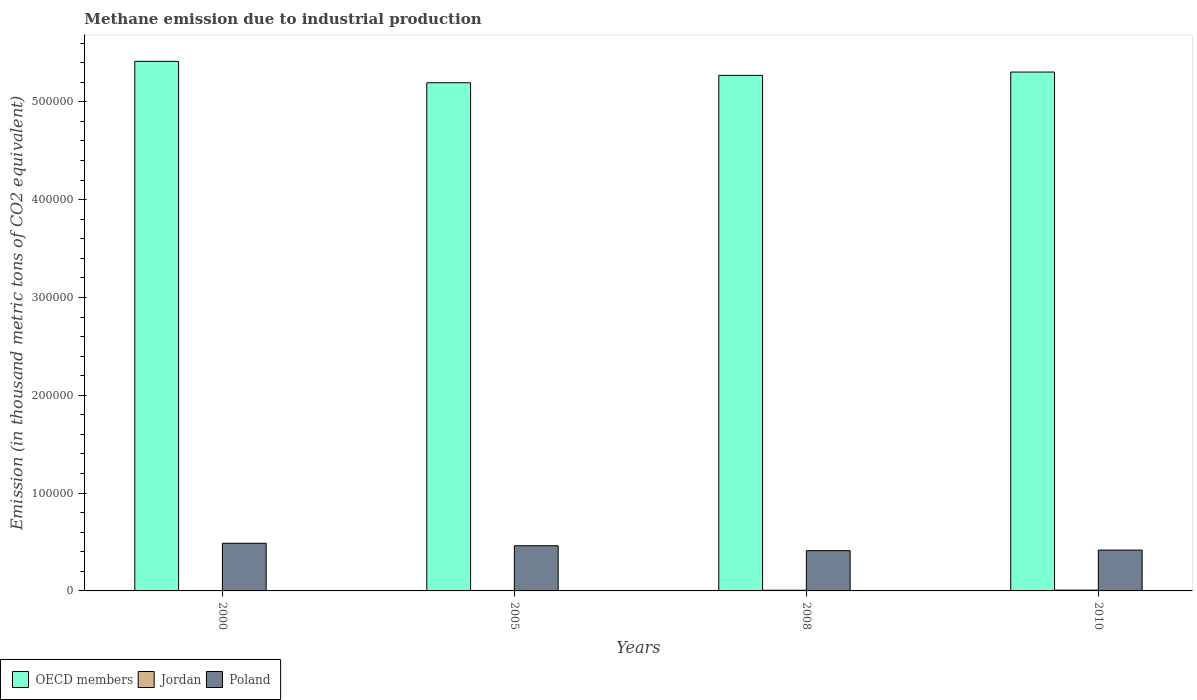How many different coloured bars are there?
Ensure brevity in your answer.  3. How many groups of bars are there?
Offer a terse response. 4. What is the label of the 4th group of bars from the left?
Offer a terse response. 2010. What is the amount of methane emitted in Jordan in 2008?
Provide a short and direct response. 681.7. Across all years, what is the maximum amount of methane emitted in Poland?
Provide a short and direct response. 4.87e+04. Across all years, what is the minimum amount of methane emitted in Poland?
Your answer should be compact. 4.12e+04. What is the total amount of methane emitted in Poland in the graph?
Your response must be concise. 1.78e+05. What is the difference between the amount of methane emitted in Jordan in 2008 and that in 2010?
Ensure brevity in your answer.  -123.7. What is the difference between the amount of methane emitted in Poland in 2008 and the amount of methane emitted in Jordan in 2000?
Your answer should be very brief. 4.09e+04. What is the average amount of methane emitted in OECD members per year?
Ensure brevity in your answer.  5.30e+05. In the year 2005, what is the difference between the amount of methane emitted in Poland and amount of methane emitted in OECD members?
Your response must be concise. -4.73e+05. In how many years, is the amount of methane emitted in Poland greater than 20000 thousand metric tons?
Your answer should be compact. 4. What is the ratio of the amount of methane emitted in Jordan in 2000 to that in 2010?
Your response must be concise. 0.29. Is the amount of methane emitted in OECD members in 2000 less than that in 2010?
Make the answer very short. No. What is the difference between the highest and the second highest amount of methane emitted in Poland?
Keep it short and to the point. 2536.5. What is the difference between the highest and the lowest amount of methane emitted in Poland?
Your response must be concise. 7532.6. In how many years, is the amount of methane emitted in Poland greater than the average amount of methane emitted in Poland taken over all years?
Give a very brief answer. 2. What does the 2nd bar from the left in 2000 represents?
Ensure brevity in your answer.  Jordan. Is it the case that in every year, the sum of the amount of methane emitted in OECD members and amount of methane emitted in Poland is greater than the amount of methane emitted in Jordan?
Keep it short and to the point. Yes. How many bars are there?
Your response must be concise. 12. How many years are there in the graph?
Offer a terse response. 4. What is the difference between two consecutive major ticks on the Y-axis?
Keep it short and to the point. 1.00e+05. Are the values on the major ticks of Y-axis written in scientific E-notation?
Make the answer very short. No. Does the graph contain grids?
Make the answer very short. No. How many legend labels are there?
Provide a succinct answer. 3. What is the title of the graph?
Your answer should be very brief. Methane emission due to industrial production. What is the label or title of the Y-axis?
Keep it short and to the point. Emission (in thousand metric tons of CO2 equivalent). What is the Emission (in thousand metric tons of CO2 equivalent) in OECD members in 2000?
Make the answer very short. 5.41e+05. What is the Emission (in thousand metric tons of CO2 equivalent) of Jordan in 2000?
Ensure brevity in your answer.  231.4. What is the Emission (in thousand metric tons of CO2 equivalent) in Poland in 2000?
Give a very brief answer. 4.87e+04. What is the Emission (in thousand metric tons of CO2 equivalent) of OECD members in 2005?
Your response must be concise. 5.19e+05. What is the Emission (in thousand metric tons of CO2 equivalent) of Jordan in 2005?
Your answer should be compact. 486.3. What is the Emission (in thousand metric tons of CO2 equivalent) of Poland in 2005?
Provide a short and direct response. 4.62e+04. What is the Emission (in thousand metric tons of CO2 equivalent) of OECD members in 2008?
Ensure brevity in your answer.  5.27e+05. What is the Emission (in thousand metric tons of CO2 equivalent) in Jordan in 2008?
Your response must be concise. 681.7. What is the Emission (in thousand metric tons of CO2 equivalent) of Poland in 2008?
Keep it short and to the point. 4.12e+04. What is the Emission (in thousand metric tons of CO2 equivalent) of OECD members in 2010?
Offer a terse response. 5.30e+05. What is the Emission (in thousand metric tons of CO2 equivalent) in Jordan in 2010?
Keep it short and to the point. 805.4. What is the Emission (in thousand metric tons of CO2 equivalent) of Poland in 2010?
Your response must be concise. 4.17e+04. Across all years, what is the maximum Emission (in thousand metric tons of CO2 equivalent) in OECD members?
Make the answer very short. 5.41e+05. Across all years, what is the maximum Emission (in thousand metric tons of CO2 equivalent) in Jordan?
Offer a terse response. 805.4. Across all years, what is the maximum Emission (in thousand metric tons of CO2 equivalent) in Poland?
Give a very brief answer. 4.87e+04. Across all years, what is the minimum Emission (in thousand metric tons of CO2 equivalent) in OECD members?
Ensure brevity in your answer.  5.19e+05. Across all years, what is the minimum Emission (in thousand metric tons of CO2 equivalent) in Jordan?
Keep it short and to the point. 231.4. Across all years, what is the minimum Emission (in thousand metric tons of CO2 equivalent) in Poland?
Your answer should be compact. 4.12e+04. What is the total Emission (in thousand metric tons of CO2 equivalent) of OECD members in the graph?
Your response must be concise. 2.12e+06. What is the total Emission (in thousand metric tons of CO2 equivalent) of Jordan in the graph?
Make the answer very short. 2204.8. What is the total Emission (in thousand metric tons of CO2 equivalent) in Poland in the graph?
Your response must be concise. 1.78e+05. What is the difference between the Emission (in thousand metric tons of CO2 equivalent) in OECD members in 2000 and that in 2005?
Provide a short and direct response. 2.19e+04. What is the difference between the Emission (in thousand metric tons of CO2 equivalent) in Jordan in 2000 and that in 2005?
Ensure brevity in your answer.  -254.9. What is the difference between the Emission (in thousand metric tons of CO2 equivalent) in Poland in 2000 and that in 2005?
Offer a terse response. 2536.5. What is the difference between the Emission (in thousand metric tons of CO2 equivalent) of OECD members in 2000 and that in 2008?
Offer a very short reply. 1.43e+04. What is the difference between the Emission (in thousand metric tons of CO2 equivalent) of Jordan in 2000 and that in 2008?
Your answer should be very brief. -450.3. What is the difference between the Emission (in thousand metric tons of CO2 equivalent) of Poland in 2000 and that in 2008?
Your answer should be compact. 7532.6. What is the difference between the Emission (in thousand metric tons of CO2 equivalent) in OECD members in 2000 and that in 2010?
Your response must be concise. 1.09e+04. What is the difference between the Emission (in thousand metric tons of CO2 equivalent) of Jordan in 2000 and that in 2010?
Offer a terse response. -574. What is the difference between the Emission (in thousand metric tons of CO2 equivalent) in Poland in 2000 and that in 2010?
Your answer should be compact. 6963.4. What is the difference between the Emission (in thousand metric tons of CO2 equivalent) in OECD members in 2005 and that in 2008?
Make the answer very short. -7540.4. What is the difference between the Emission (in thousand metric tons of CO2 equivalent) of Jordan in 2005 and that in 2008?
Your answer should be very brief. -195.4. What is the difference between the Emission (in thousand metric tons of CO2 equivalent) of Poland in 2005 and that in 2008?
Your response must be concise. 4996.1. What is the difference between the Emission (in thousand metric tons of CO2 equivalent) in OECD members in 2005 and that in 2010?
Offer a terse response. -1.09e+04. What is the difference between the Emission (in thousand metric tons of CO2 equivalent) in Jordan in 2005 and that in 2010?
Offer a very short reply. -319.1. What is the difference between the Emission (in thousand metric tons of CO2 equivalent) in Poland in 2005 and that in 2010?
Your answer should be very brief. 4426.9. What is the difference between the Emission (in thousand metric tons of CO2 equivalent) in OECD members in 2008 and that in 2010?
Provide a succinct answer. -3406. What is the difference between the Emission (in thousand metric tons of CO2 equivalent) of Jordan in 2008 and that in 2010?
Provide a succinct answer. -123.7. What is the difference between the Emission (in thousand metric tons of CO2 equivalent) of Poland in 2008 and that in 2010?
Provide a succinct answer. -569.2. What is the difference between the Emission (in thousand metric tons of CO2 equivalent) in OECD members in 2000 and the Emission (in thousand metric tons of CO2 equivalent) in Jordan in 2005?
Your answer should be compact. 5.41e+05. What is the difference between the Emission (in thousand metric tons of CO2 equivalent) of OECD members in 2000 and the Emission (in thousand metric tons of CO2 equivalent) of Poland in 2005?
Your answer should be compact. 4.95e+05. What is the difference between the Emission (in thousand metric tons of CO2 equivalent) of Jordan in 2000 and the Emission (in thousand metric tons of CO2 equivalent) of Poland in 2005?
Provide a succinct answer. -4.59e+04. What is the difference between the Emission (in thousand metric tons of CO2 equivalent) of OECD members in 2000 and the Emission (in thousand metric tons of CO2 equivalent) of Jordan in 2008?
Your response must be concise. 5.41e+05. What is the difference between the Emission (in thousand metric tons of CO2 equivalent) in OECD members in 2000 and the Emission (in thousand metric tons of CO2 equivalent) in Poland in 2008?
Provide a succinct answer. 5.00e+05. What is the difference between the Emission (in thousand metric tons of CO2 equivalent) in Jordan in 2000 and the Emission (in thousand metric tons of CO2 equivalent) in Poland in 2008?
Your answer should be compact. -4.09e+04. What is the difference between the Emission (in thousand metric tons of CO2 equivalent) in OECD members in 2000 and the Emission (in thousand metric tons of CO2 equivalent) in Jordan in 2010?
Provide a short and direct response. 5.41e+05. What is the difference between the Emission (in thousand metric tons of CO2 equivalent) of OECD members in 2000 and the Emission (in thousand metric tons of CO2 equivalent) of Poland in 2010?
Your answer should be compact. 5.00e+05. What is the difference between the Emission (in thousand metric tons of CO2 equivalent) in Jordan in 2000 and the Emission (in thousand metric tons of CO2 equivalent) in Poland in 2010?
Your response must be concise. -4.15e+04. What is the difference between the Emission (in thousand metric tons of CO2 equivalent) of OECD members in 2005 and the Emission (in thousand metric tons of CO2 equivalent) of Jordan in 2008?
Provide a succinct answer. 5.19e+05. What is the difference between the Emission (in thousand metric tons of CO2 equivalent) in OECD members in 2005 and the Emission (in thousand metric tons of CO2 equivalent) in Poland in 2008?
Keep it short and to the point. 4.78e+05. What is the difference between the Emission (in thousand metric tons of CO2 equivalent) of Jordan in 2005 and the Emission (in thousand metric tons of CO2 equivalent) of Poland in 2008?
Offer a very short reply. -4.07e+04. What is the difference between the Emission (in thousand metric tons of CO2 equivalent) in OECD members in 2005 and the Emission (in thousand metric tons of CO2 equivalent) in Jordan in 2010?
Provide a short and direct response. 5.19e+05. What is the difference between the Emission (in thousand metric tons of CO2 equivalent) of OECD members in 2005 and the Emission (in thousand metric tons of CO2 equivalent) of Poland in 2010?
Offer a very short reply. 4.78e+05. What is the difference between the Emission (in thousand metric tons of CO2 equivalent) in Jordan in 2005 and the Emission (in thousand metric tons of CO2 equivalent) in Poland in 2010?
Offer a terse response. -4.13e+04. What is the difference between the Emission (in thousand metric tons of CO2 equivalent) of OECD members in 2008 and the Emission (in thousand metric tons of CO2 equivalent) of Jordan in 2010?
Offer a terse response. 5.26e+05. What is the difference between the Emission (in thousand metric tons of CO2 equivalent) of OECD members in 2008 and the Emission (in thousand metric tons of CO2 equivalent) of Poland in 2010?
Offer a very short reply. 4.85e+05. What is the difference between the Emission (in thousand metric tons of CO2 equivalent) of Jordan in 2008 and the Emission (in thousand metric tons of CO2 equivalent) of Poland in 2010?
Make the answer very short. -4.11e+04. What is the average Emission (in thousand metric tons of CO2 equivalent) of OECD members per year?
Offer a very short reply. 5.30e+05. What is the average Emission (in thousand metric tons of CO2 equivalent) in Jordan per year?
Provide a short and direct response. 551.2. What is the average Emission (in thousand metric tons of CO2 equivalent) in Poland per year?
Offer a terse response. 4.44e+04. In the year 2000, what is the difference between the Emission (in thousand metric tons of CO2 equivalent) in OECD members and Emission (in thousand metric tons of CO2 equivalent) in Jordan?
Offer a terse response. 5.41e+05. In the year 2000, what is the difference between the Emission (in thousand metric tons of CO2 equivalent) of OECD members and Emission (in thousand metric tons of CO2 equivalent) of Poland?
Give a very brief answer. 4.93e+05. In the year 2000, what is the difference between the Emission (in thousand metric tons of CO2 equivalent) in Jordan and Emission (in thousand metric tons of CO2 equivalent) in Poland?
Your answer should be compact. -4.85e+04. In the year 2005, what is the difference between the Emission (in thousand metric tons of CO2 equivalent) of OECD members and Emission (in thousand metric tons of CO2 equivalent) of Jordan?
Provide a succinct answer. 5.19e+05. In the year 2005, what is the difference between the Emission (in thousand metric tons of CO2 equivalent) of OECD members and Emission (in thousand metric tons of CO2 equivalent) of Poland?
Give a very brief answer. 4.73e+05. In the year 2005, what is the difference between the Emission (in thousand metric tons of CO2 equivalent) in Jordan and Emission (in thousand metric tons of CO2 equivalent) in Poland?
Offer a terse response. -4.57e+04. In the year 2008, what is the difference between the Emission (in thousand metric tons of CO2 equivalent) of OECD members and Emission (in thousand metric tons of CO2 equivalent) of Jordan?
Provide a succinct answer. 5.26e+05. In the year 2008, what is the difference between the Emission (in thousand metric tons of CO2 equivalent) in OECD members and Emission (in thousand metric tons of CO2 equivalent) in Poland?
Offer a terse response. 4.86e+05. In the year 2008, what is the difference between the Emission (in thousand metric tons of CO2 equivalent) in Jordan and Emission (in thousand metric tons of CO2 equivalent) in Poland?
Provide a short and direct response. -4.05e+04. In the year 2010, what is the difference between the Emission (in thousand metric tons of CO2 equivalent) in OECD members and Emission (in thousand metric tons of CO2 equivalent) in Jordan?
Offer a very short reply. 5.30e+05. In the year 2010, what is the difference between the Emission (in thousand metric tons of CO2 equivalent) in OECD members and Emission (in thousand metric tons of CO2 equivalent) in Poland?
Provide a short and direct response. 4.89e+05. In the year 2010, what is the difference between the Emission (in thousand metric tons of CO2 equivalent) in Jordan and Emission (in thousand metric tons of CO2 equivalent) in Poland?
Provide a succinct answer. -4.09e+04. What is the ratio of the Emission (in thousand metric tons of CO2 equivalent) of OECD members in 2000 to that in 2005?
Offer a very short reply. 1.04. What is the ratio of the Emission (in thousand metric tons of CO2 equivalent) in Jordan in 2000 to that in 2005?
Offer a very short reply. 0.48. What is the ratio of the Emission (in thousand metric tons of CO2 equivalent) in Poland in 2000 to that in 2005?
Your answer should be very brief. 1.05. What is the ratio of the Emission (in thousand metric tons of CO2 equivalent) of OECD members in 2000 to that in 2008?
Offer a terse response. 1.03. What is the ratio of the Emission (in thousand metric tons of CO2 equivalent) in Jordan in 2000 to that in 2008?
Your answer should be compact. 0.34. What is the ratio of the Emission (in thousand metric tons of CO2 equivalent) of Poland in 2000 to that in 2008?
Keep it short and to the point. 1.18. What is the ratio of the Emission (in thousand metric tons of CO2 equivalent) of OECD members in 2000 to that in 2010?
Offer a terse response. 1.02. What is the ratio of the Emission (in thousand metric tons of CO2 equivalent) of Jordan in 2000 to that in 2010?
Make the answer very short. 0.29. What is the ratio of the Emission (in thousand metric tons of CO2 equivalent) of Poland in 2000 to that in 2010?
Ensure brevity in your answer.  1.17. What is the ratio of the Emission (in thousand metric tons of CO2 equivalent) of OECD members in 2005 to that in 2008?
Your answer should be compact. 0.99. What is the ratio of the Emission (in thousand metric tons of CO2 equivalent) in Jordan in 2005 to that in 2008?
Ensure brevity in your answer.  0.71. What is the ratio of the Emission (in thousand metric tons of CO2 equivalent) of Poland in 2005 to that in 2008?
Provide a succinct answer. 1.12. What is the ratio of the Emission (in thousand metric tons of CO2 equivalent) of OECD members in 2005 to that in 2010?
Ensure brevity in your answer.  0.98. What is the ratio of the Emission (in thousand metric tons of CO2 equivalent) of Jordan in 2005 to that in 2010?
Keep it short and to the point. 0.6. What is the ratio of the Emission (in thousand metric tons of CO2 equivalent) in Poland in 2005 to that in 2010?
Offer a very short reply. 1.11. What is the ratio of the Emission (in thousand metric tons of CO2 equivalent) of Jordan in 2008 to that in 2010?
Keep it short and to the point. 0.85. What is the ratio of the Emission (in thousand metric tons of CO2 equivalent) in Poland in 2008 to that in 2010?
Offer a very short reply. 0.99. What is the difference between the highest and the second highest Emission (in thousand metric tons of CO2 equivalent) of OECD members?
Offer a very short reply. 1.09e+04. What is the difference between the highest and the second highest Emission (in thousand metric tons of CO2 equivalent) in Jordan?
Your answer should be very brief. 123.7. What is the difference between the highest and the second highest Emission (in thousand metric tons of CO2 equivalent) in Poland?
Provide a short and direct response. 2536.5. What is the difference between the highest and the lowest Emission (in thousand metric tons of CO2 equivalent) in OECD members?
Offer a terse response. 2.19e+04. What is the difference between the highest and the lowest Emission (in thousand metric tons of CO2 equivalent) in Jordan?
Ensure brevity in your answer.  574. What is the difference between the highest and the lowest Emission (in thousand metric tons of CO2 equivalent) of Poland?
Provide a succinct answer. 7532.6. 